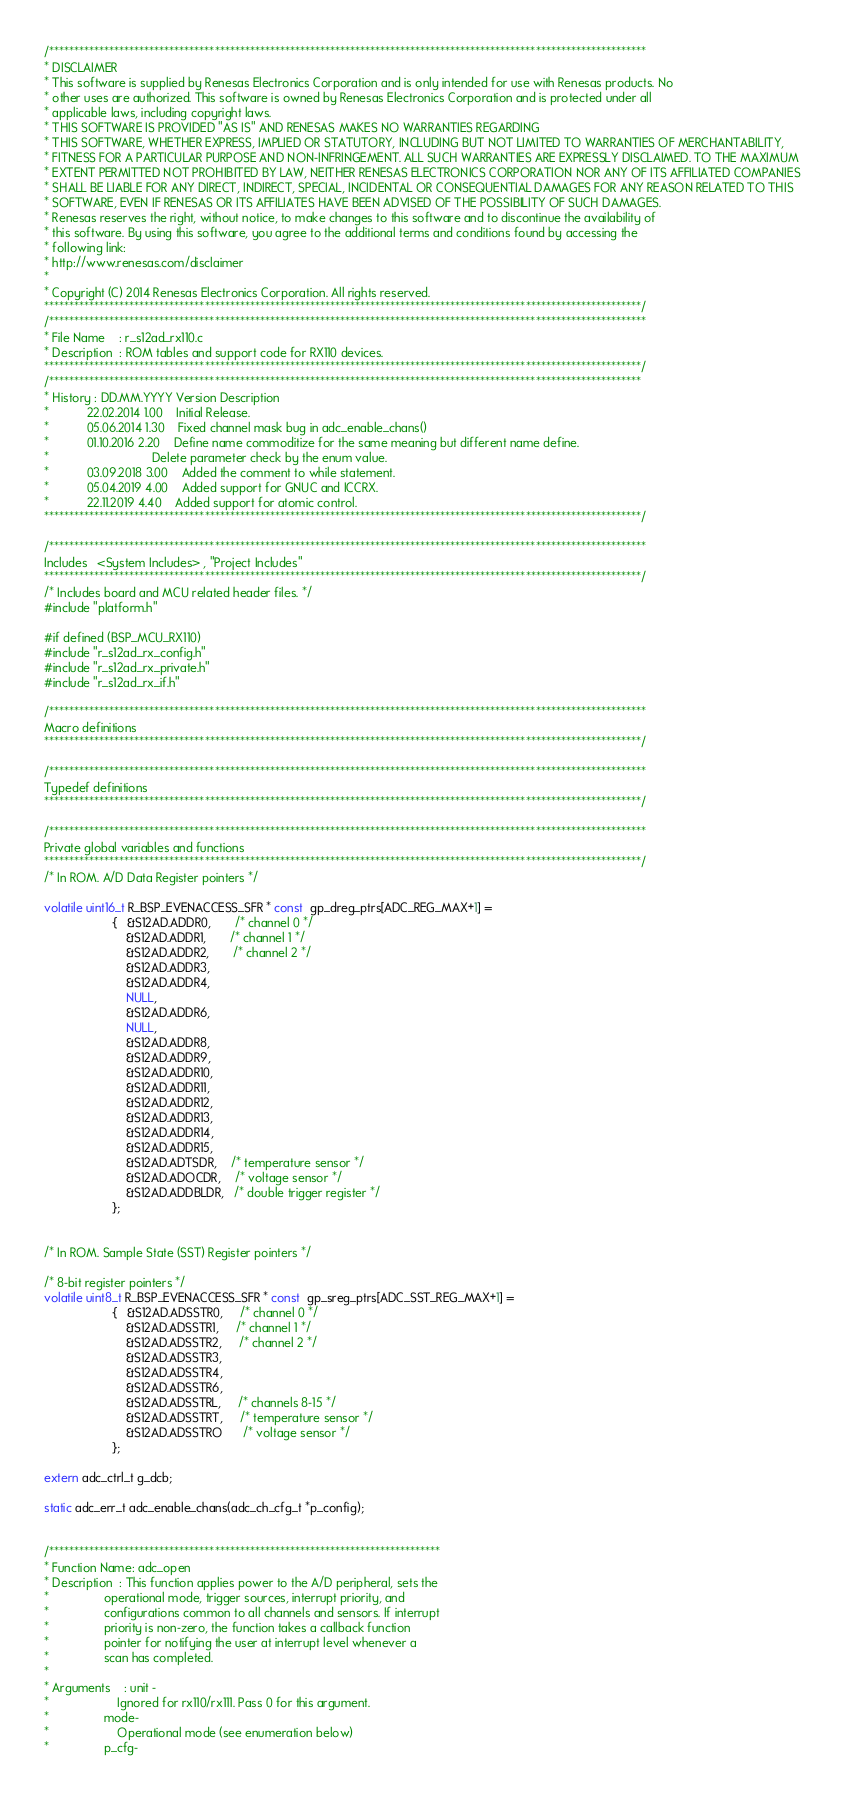<code> <loc_0><loc_0><loc_500><loc_500><_C_>/***********************************************************************************************************************
* DISCLAIMER
* This software is supplied by Renesas Electronics Corporation and is only intended for use with Renesas products. No 
* other uses are authorized. This software is owned by Renesas Electronics Corporation and is protected under all 
* applicable laws, including copyright laws. 
* THIS SOFTWARE IS PROVIDED "AS IS" AND RENESAS MAKES NO WARRANTIES REGARDING
* THIS SOFTWARE, WHETHER EXPRESS, IMPLIED OR STATUTORY, INCLUDING BUT NOT LIMITED TO WARRANTIES OF MERCHANTABILITY, 
* FITNESS FOR A PARTICULAR PURPOSE AND NON-INFRINGEMENT. ALL SUCH WARRANTIES ARE EXPRESSLY DISCLAIMED. TO THE MAXIMUM 
* EXTENT PERMITTED NOT PROHIBITED BY LAW, NEITHER RENESAS ELECTRONICS CORPORATION NOR ANY OF ITS AFFILIATED COMPANIES 
* SHALL BE LIABLE FOR ANY DIRECT, INDIRECT, SPECIAL, INCIDENTAL OR CONSEQUENTIAL DAMAGES FOR ANY REASON RELATED TO THIS 
* SOFTWARE, EVEN IF RENESAS OR ITS AFFILIATES HAVE BEEN ADVISED OF THE POSSIBILITY OF SUCH DAMAGES.
* Renesas reserves the right, without notice, to make changes to this software and to discontinue the availability of 
* this software. By using this software, you agree to the additional terms and conditions found by accessing the 
* following link:
* http://www.renesas.com/disclaimer
*
* Copyright (C) 2014 Renesas Electronics Corporation. All rights reserved.
***********************************************************************************************************************/
/***********************************************************************************************************************
* File Name    : r_s12ad_rx110.c
* Description  : ROM tables and support code for RX110 devices.
***********************************************************************************************************************/
/**********************************************************************************************************************
* History : DD.MM.YYYY Version Description
*           22.02.2014 1.00    Initial Release.
*           05.06.2014 1.30    Fixed channel mask bug in adc_enable_chans()
*           01.10.2016 2.20    Define name commoditize for the same meaning but different name define.
*                              Delete parameter check by the enum value.
*           03.09.2018 3.00    Added the comment to while statement.
*           05.04.2019 4.00    Added support for GNUC and ICCRX.
*           22.11.2019 4.40    Added support for atomic control.
***********************************************************************************************************************/

/***********************************************************************************************************************
Includes   <System Includes> , "Project Includes"
***********************************************************************************************************************/
/* Includes board and MCU related header files. */
#include "platform.h"

#if defined (BSP_MCU_RX110)
#include "r_s12ad_rx_config.h"
#include "r_s12ad_rx_private.h"
#include "r_s12ad_rx_if.h"

/***********************************************************************************************************************
Macro definitions
***********************************************************************************************************************/

/***********************************************************************************************************************
Typedef definitions
***********************************************************************************************************************/

/***********************************************************************************************************************
Private global variables and functions
***********************************************************************************************************************/
/* In ROM. A/D Data Register pointers */

volatile uint16_t R_BSP_EVENACCESS_SFR * const  gp_dreg_ptrs[ADC_REG_MAX+1] =
                    {   &S12AD.ADDR0,       /* channel 0 */
                        &S12AD.ADDR1,       /* channel 1 */
                        &S12AD.ADDR2,       /* channel 2 */
                        &S12AD.ADDR3,
                        &S12AD.ADDR4,
                        NULL,
                        &S12AD.ADDR6,
                        NULL,
                        &S12AD.ADDR8,
                        &S12AD.ADDR9,
                        &S12AD.ADDR10,
                        &S12AD.ADDR11,
                        &S12AD.ADDR12,
                        &S12AD.ADDR13,
                        &S12AD.ADDR14,
                        &S12AD.ADDR15,
                        &S12AD.ADTSDR,    /* temperature sensor */
                        &S12AD.ADOCDR,    /* voltage sensor */
                        &S12AD.ADDBLDR,   /* double trigger register */
                    };


/* In ROM. Sample State (SST) Register pointers */

/* 8-bit register pointers */
volatile uint8_t R_BSP_EVENACCESS_SFR * const  gp_sreg_ptrs[ADC_SST_REG_MAX+1] =
                    {   &S12AD.ADSSTR0,     /* channel 0 */
                        &S12AD.ADSSTR1,     /* channel 1 */
                        &S12AD.ADSSTR2,     /* channel 2 */
                        &S12AD.ADSSTR3,
                        &S12AD.ADSSTR4,
                        &S12AD.ADSSTR6,
                        &S12AD.ADSSTRL,     /* channels 8-15 */
                        &S12AD.ADSSTRT,     /* temperature sensor */
                        &S12AD.ADSSTRO      /* voltage sensor */
                    };

extern adc_ctrl_t g_dcb;

static adc_err_t adc_enable_chans(adc_ch_cfg_t *p_config);


/******************************************************************************
* Function Name: adc_open
* Description  : This function applies power to the A/D peripheral, sets the
*                operational mode, trigger sources, interrupt priority, and
*                configurations common to all channels and sensors. If interrupt
*                priority is non-zero, the function takes a callback function
*                pointer for notifying the user at interrupt level whenever a
*                scan has completed.
*
* Arguments    : unit -
*                    Ignored for rx110/rx111. Pass 0 for this argument.
*                mode-
*                    Operational mode (see enumeration below)
*                p_cfg-</code> 